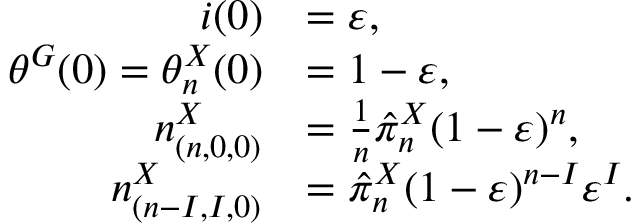Convert formula to latex. <formula><loc_0><loc_0><loc_500><loc_500>\begin{array} { r l } { i ( 0 ) } & { = \varepsilon , } \\ { \theta ^ { G } ( 0 ) = \theta _ { n } ^ { X } ( 0 ) } & { = 1 - \varepsilon , } \\ { n _ { ( n , 0 , 0 ) } ^ { X } } & { = \frac { 1 } { n } \hat { \pi } _ { n } ^ { X } ( 1 - \varepsilon ) ^ { n } , } \\ { n _ { ( n - I , I , 0 ) } ^ { X } } & { = \hat { \pi } _ { n } ^ { X } ( 1 - \varepsilon ) ^ { n - I } \varepsilon ^ { I } . } \end{array}</formula> 